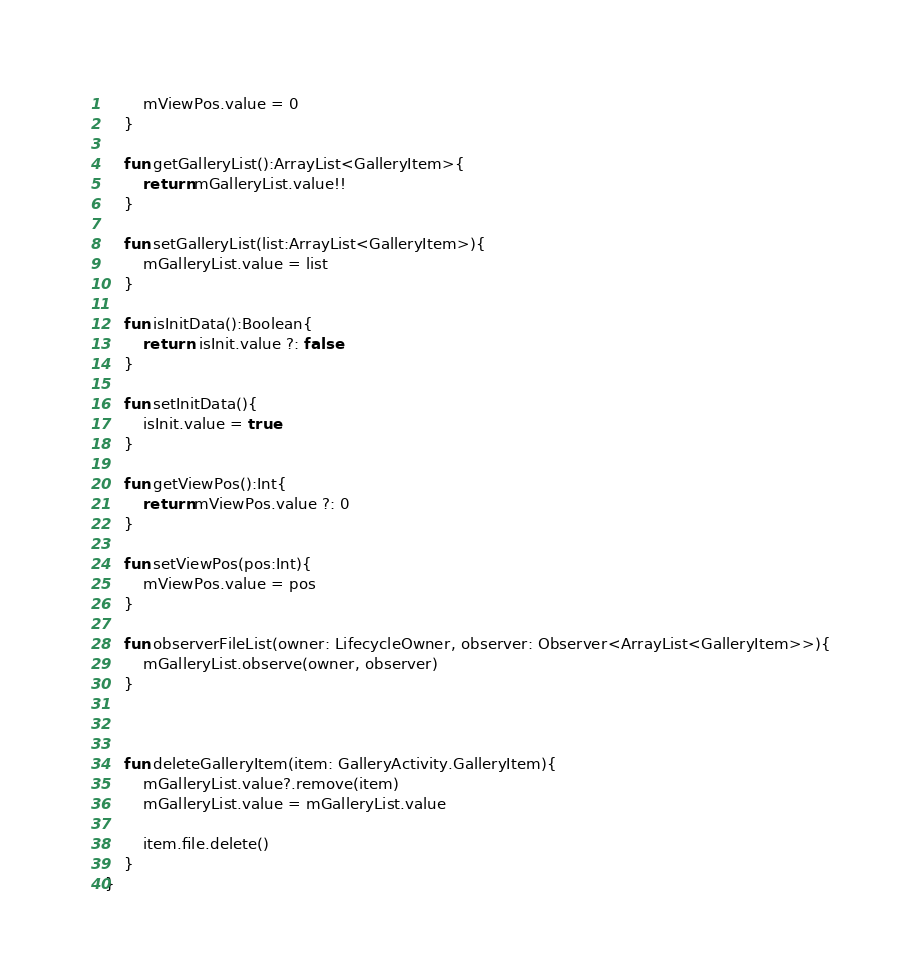<code> <loc_0><loc_0><loc_500><loc_500><_Kotlin_>        mViewPos.value = 0
    }

    fun getGalleryList():ArrayList<GalleryItem>{
        return mGalleryList.value!!
    }

    fun setGalleryList(list:ArrayList<GalleryItem>){
        mGalleryList.value = list
    }

    fun isInitData():Boolean{
        return  isInit.value ?: false
    }

    fun setInitData(){
        isInit.value = true
    }

    fun getViewPos():Int{
        return mViewPos.value ?: 0
    }

    fun setViewPos(pos:Int){
        mViewPos.value = pos
    }

    fun observerFileList(owner: LifecycleOwner, observer: Observer<ArrayList<GalleryItem>>){
        mGalleryList.observe(owner, observer)
    }



    fun deleteGalleryItem(item: GalleryActivity.GalleryItem){
        mGalleryList.value?.remove(item)
        mGalleryList.value = mGalleryList.value

        item.file.delete()
    }
}</code> 